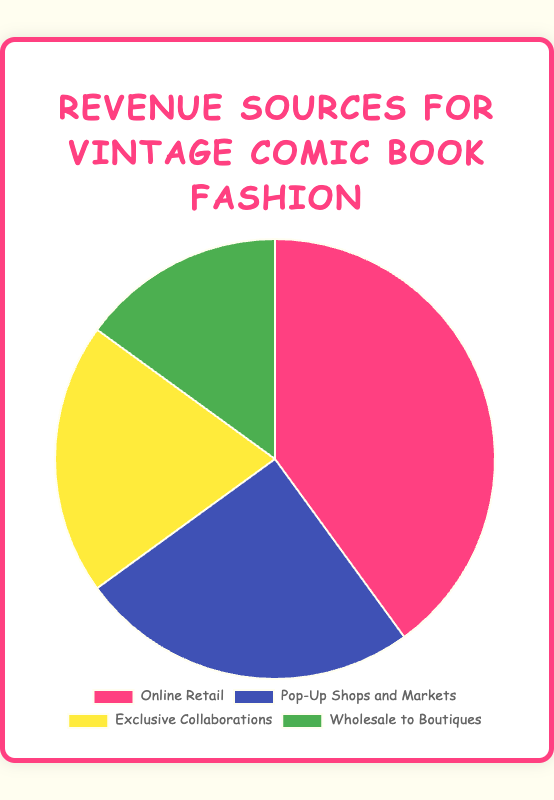Which revenue source contributes the largest percentage to the total revenue? Online Retail has the highest value at 40% as visually represented by the largest section in the pie chart.
Answer: Online Retail Which two revenue sources combined make up less than half of the total revenue? Pop-Up Shops and Markets (25%) and Wholesale to Boutiques (15%) add up to 40%, which is less than half.
Answer: Pop-Up Shops and Markets, Wholesale to Boutiques Which revenue source has the smallest share in the pie chart? The smallest segment belongs to Wholesale to Boutiques, which is 15%.
Answer: Wholesale to Boutiques How much more percentage does Online Retail generate compared to Exclusive Collaborations? Online Retail generates 40% while Exclusive Collaborations generate 20%. The difference is 40% - 20% = 20%.
Answer: 20% What is the total percentage contribution of the top two revenue sources? Online Retail (40%) and Pop-Up Shops and Markets (25%) together contribute 40% + 25% = 65%.
Answer: 65% Which revenue source depicted in green contributes what percentage of the total revenue? The green section represents Wholesale to Boutiques, which contributes 15%.
Answer: 15% If you are to calculate the average percentage share of Exclusive Collaborations and Wholesale to Boutiques, what would it be? The average is calculated as (20% + 15%) / 2 = 17.5%.
Answer: 17.5% Is the percentage share of Exclusive Collaborations closer to the share of Pop-Up Shops and Markets or Wholesale to Boutiques? The difference between Exclusive Collaborations and Pop-Up Shops and Markets is 25% - 20% = 5%. The difference between Exclusive Collaborations and Wholesale to Boutiques is 20% - 15% = 5%. Thus, it’s equally close to both.
Answer: Equally close What is the difference in percentage between the largest and smallest revenue sources? The difference is between Online Retail (40%) and Wholesale to Boutiques (15%), which is 40% - 15% = 25%.
Answer: 25% How much more percentage does Pop-Up Shops and Markets generate compared to Wholesale to Boutiques? Pop-Up Shops and Markets generates 25% while Wholesale to Boutiques generates 15%. The difference is 25% - 15% = 10%.
Answer: 10% 